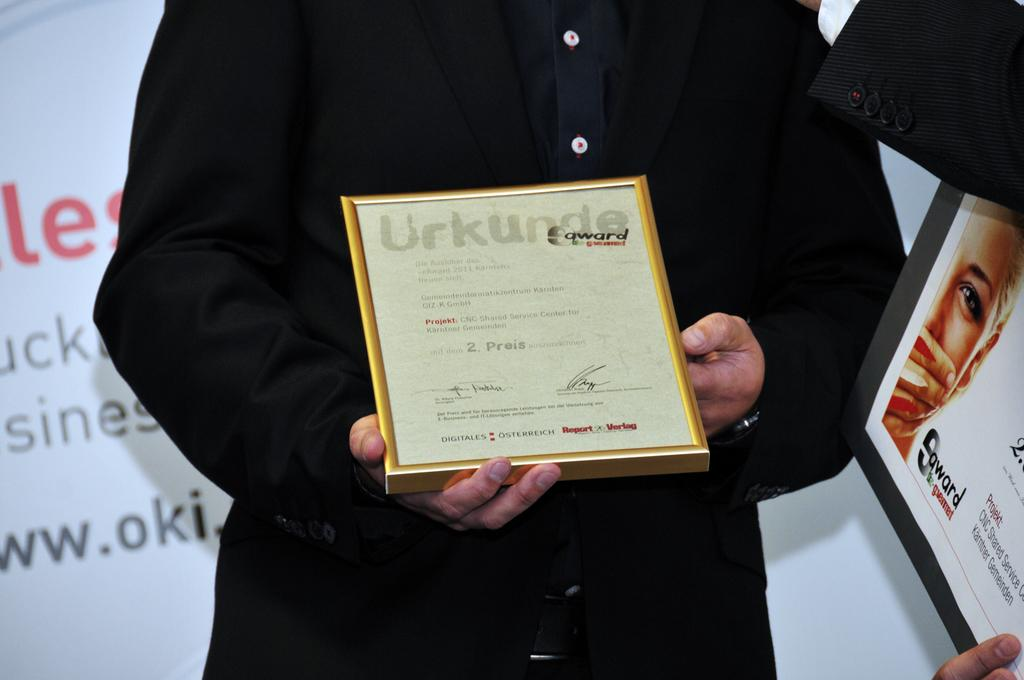What is the person in the image doing? The person is standing and holding a certificate. What might the certificate signify? The certificate might signify an achievement or recognition. What else can be seen in the image besides the person and the certificate? There are fingers of a person on a board and a board visible in the background of the image. How many lizards are playing baseball on the board in the image? There are no lizards or baseball activity present in the image. 